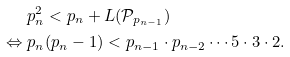Convert formula to latex. <formula><loc_0><loc_0><loc_500><loc_500>& p _ { n } ^ { 2 } < p _ { n } + L ( \mathcal { P } _ { p _ { n - 1 } } ) \\ \Leftrightarrow \ & p _ { n } ( p _ { n } - 1 ) < p _ { n - 1 } \cdot p _ { n - 2 } \cdots 5 \cdot 3 \cdot 2 . \\</formula> 